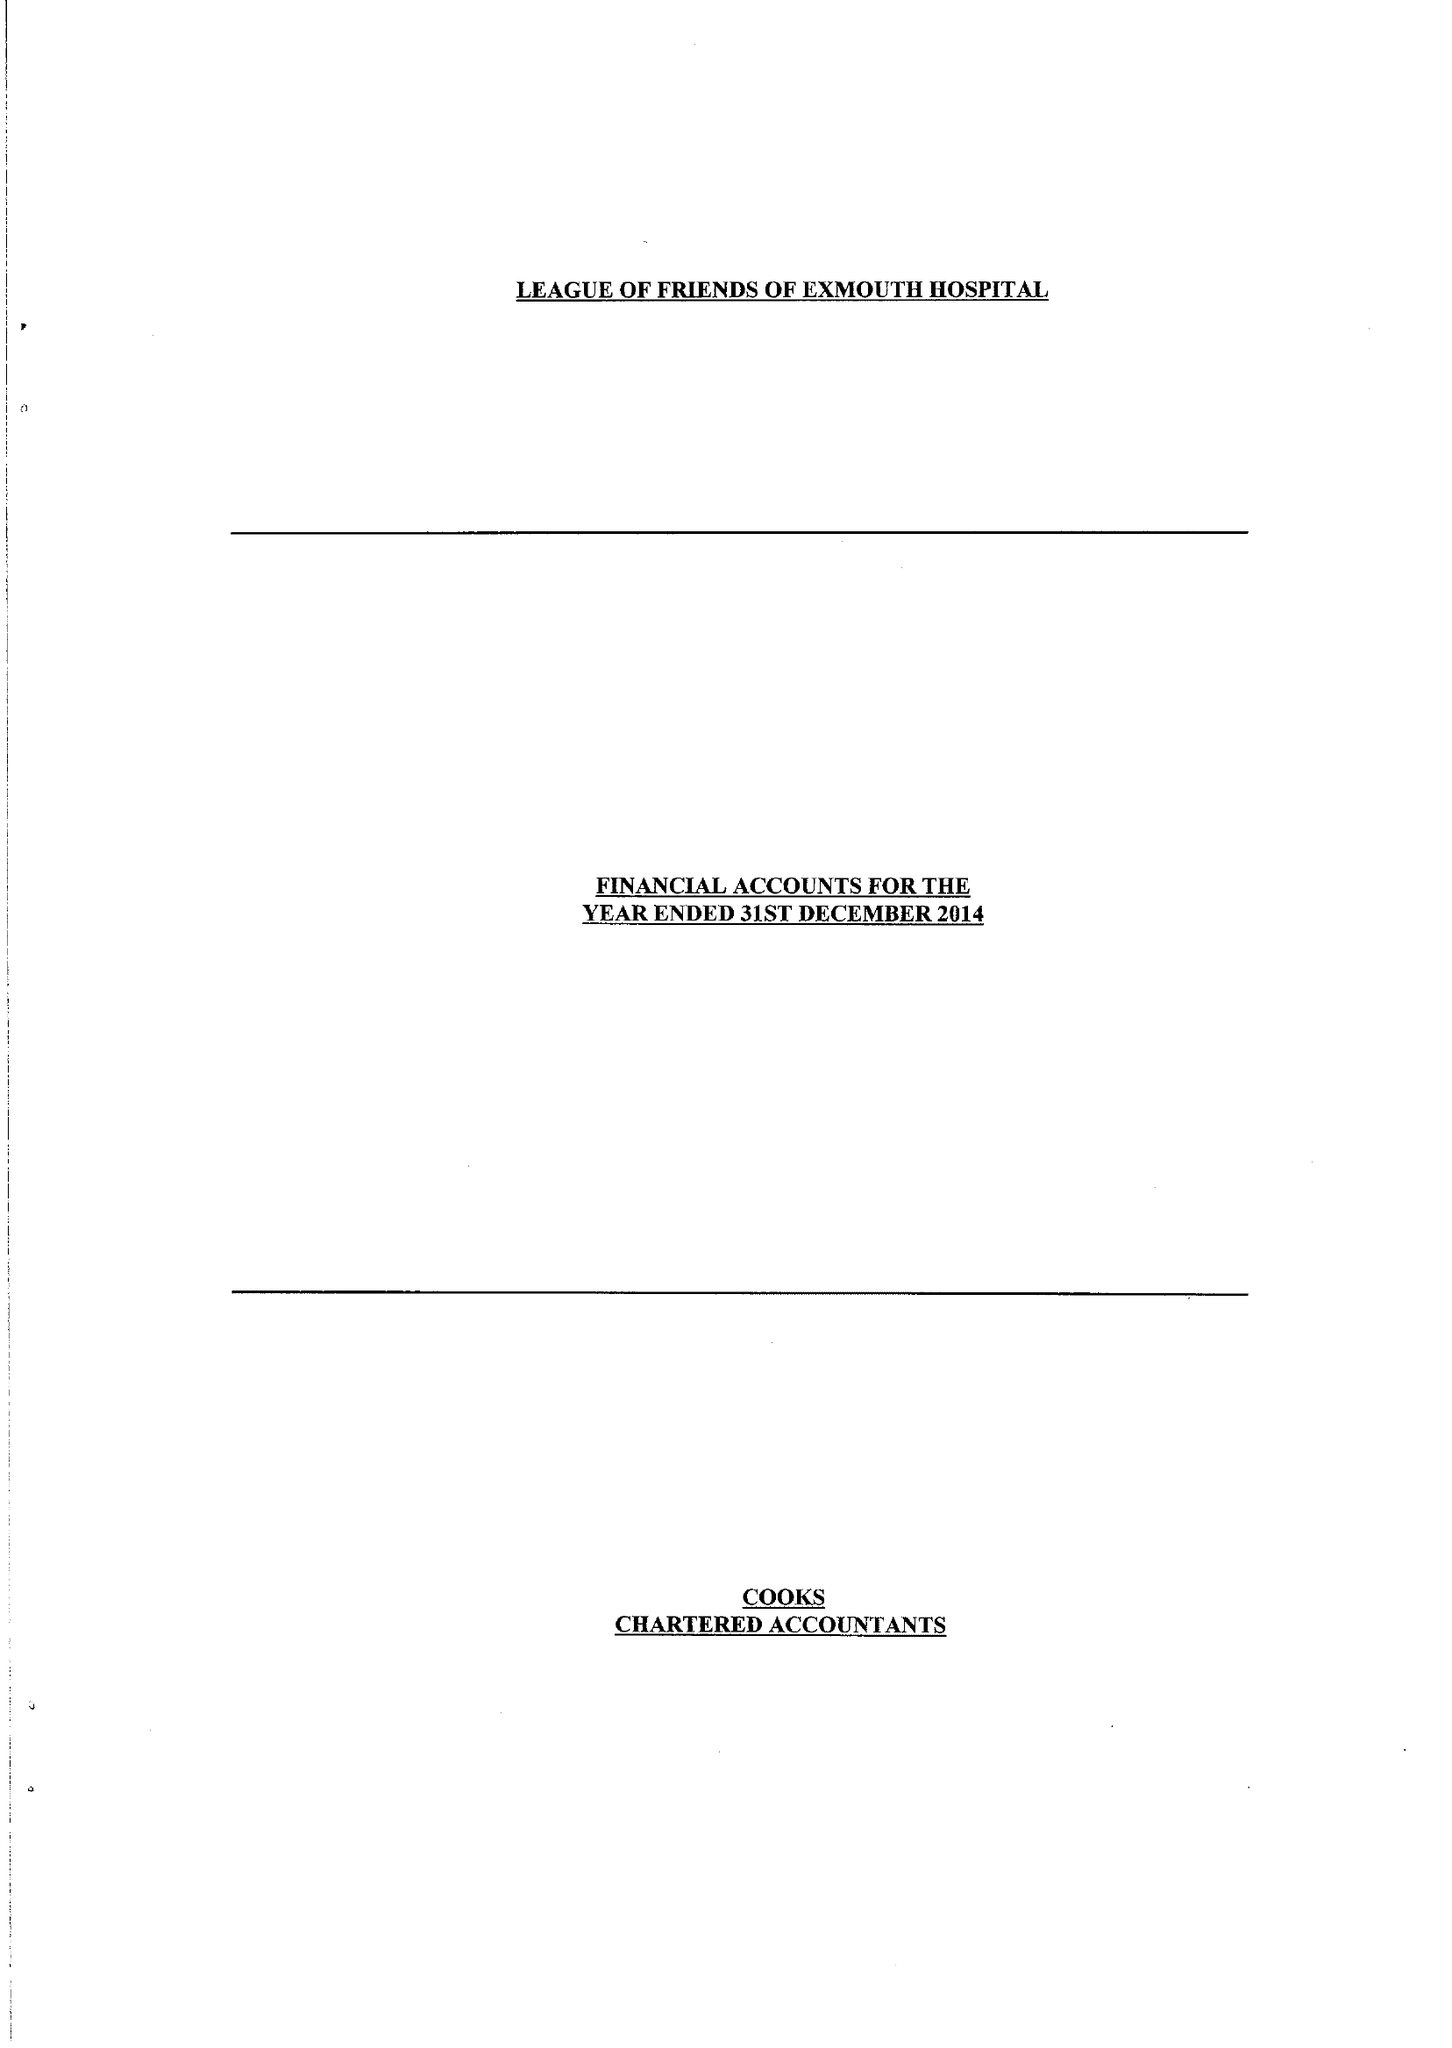What is the value for the charity_name?
Answer the question using a single word or phrase. League Of Friends Of Exmouth Hospital 